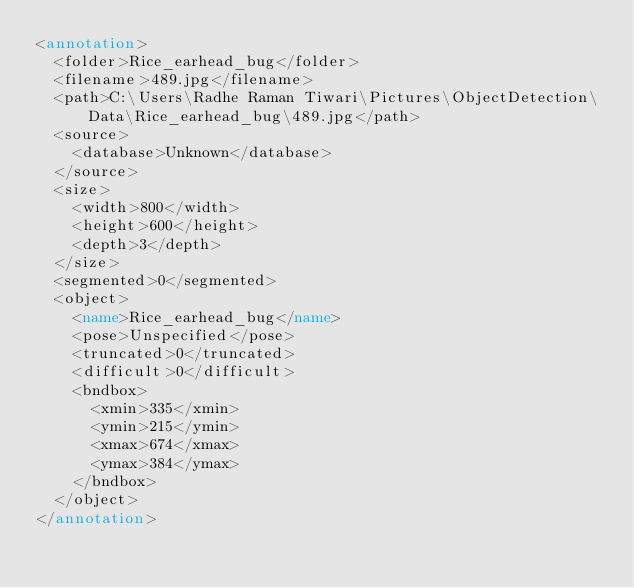Convert code to text. <code><loc_0><loc_0><loc_500><loc_500><_XML_><annotation>
	<folder>Rice_earhead_bug</folder>
	<filename>489.jpg</filename>
	<path>C:\Users\Radhe Raman Tiwari\Pictures\ObjectDetection\Data\Rice_earhead_bug\489.jpg</path>
	<source>
		<database>Unknown</database>
	</source>
	<size>
		<width>800</width>
		<height>600</height>
		<depth>3</depth>
	</size>
	<segmented>0</segmented>
	<object>
		<name>Rice_earhead_bug</name>
		<pose>Unspecified</pose>
		<truncated>0</truncated>
		<difficult>0</difficult>
		<bndbox>
			<xmin>335</xmin>
			<ymin>215</ymin>
			<xmax>674</xmax>
			<ymax>384</ymax>
		</bndbox>
	</object>
</annotation>
</code> 